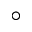Convert formula to latex. <formula><loc_0><loc_0><loc_500><loc_500>^ { \circ }</formula> 